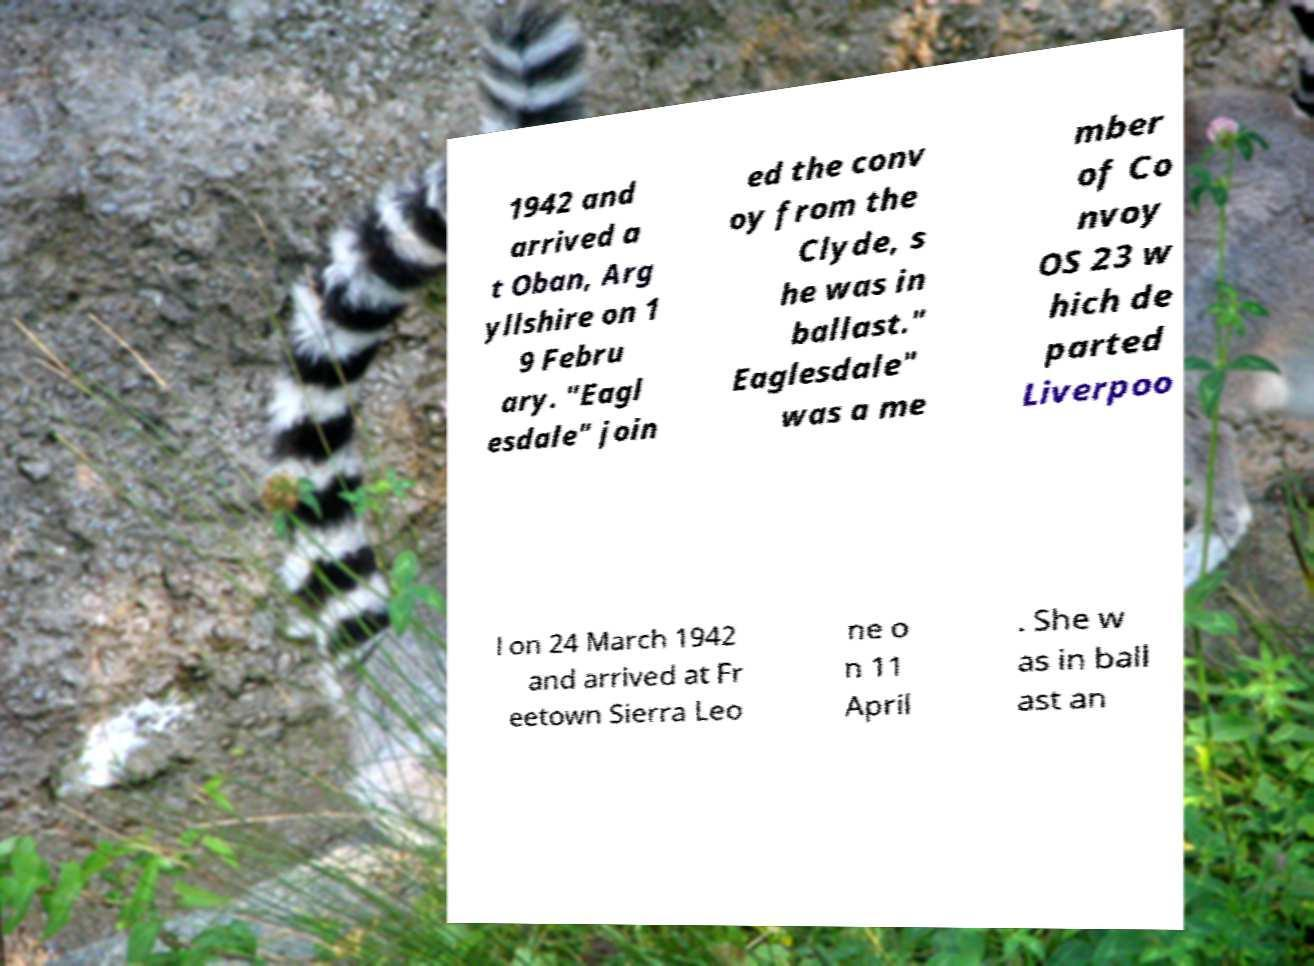Please read and relay the text visible in this image. What does it say? 1942 and arrived a t Oban, Arg yllshire on 1 9 Febru ary. "Eagl esdale" join ed the conv oy from the Clyde, s he was in ballast." Eaglesdale" was a me mber of Co nvoy OS 23 w hich de parted Liverpoo l on 24 March 1942 and arrived at Fr eetown Sierra Leo ne o n 11 April . She w as in ball ast an 